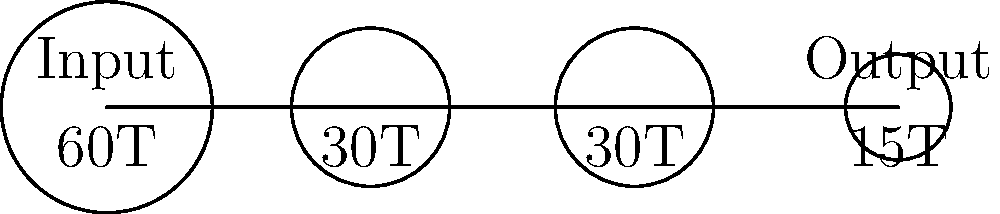A cricket scoreboard uses a gear train mechanism to display runs. The simplified gear train diagram shows four gears with teeth counts of 60, 30, 30, and 15 respectively. If the input gear (60T) rotates once, how many times will the output gear (15T) rotate? To solve this problem, we need to calculate the overall gear ratio of the system. Let's break it down step-by-step:

1) First, let's understand what gear ratio means:
   Gear ratio = (Number of teeth on driven gear) / (Number of teeth on driving gear)

2) Now, let's calculate the gear ratio for each pair:
   a) First pair (60T to 30T): $\frac{30}{60} = \frac{1}{2}$
   b) Second pair (30T to 30T): $\frac{30}{30} = 1$
   c) Third pair (30T to 15T): $\frac{15}{30} = \frac{1}{2}$

3) The overall gear ratio is the product of individual gear ratios:
   Overall ratio = $\frac{1}{2} \times 1 \times \frac{1}{2} = \frac{1}{4}$

4) This means that for every 1 rotation of the input gear, the output gear will rotate 4 times.

5) Therefore, when the input gear (60T) rotates once, the output gear (15T) will rotate 4 times.
Answer: 4 times 